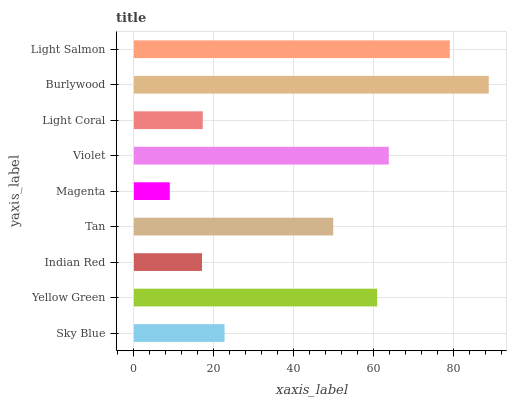Is Magenta the minimum?
Answer yes or no. Yes. Is Burlywood the maximum?
Answer yes or no. Yes. Is Yellow Green the minimum?
Answer yes or no. No. Is Yellow Green the maximum?
Answer yes or no. No. Is Yellow Green greater than Sky Blue?
Answer yes or no. Yes. Is Sky Blue less than Yellow Green?
Answer yes or no. Yes. Is Sky Blue greater than Yellow Green?
Answer yes or no. No. Is Yellow Green less than Sky Blue?
Answer yes or no. No. Is Tan the high median?
Answer yes or no. Yes. Is Tan the low median?
Answer yes or no. Yes. Is Burlywood the high median?
Answer yes or no. No. Is Magenta the low median?
Answer yes or no. No. 